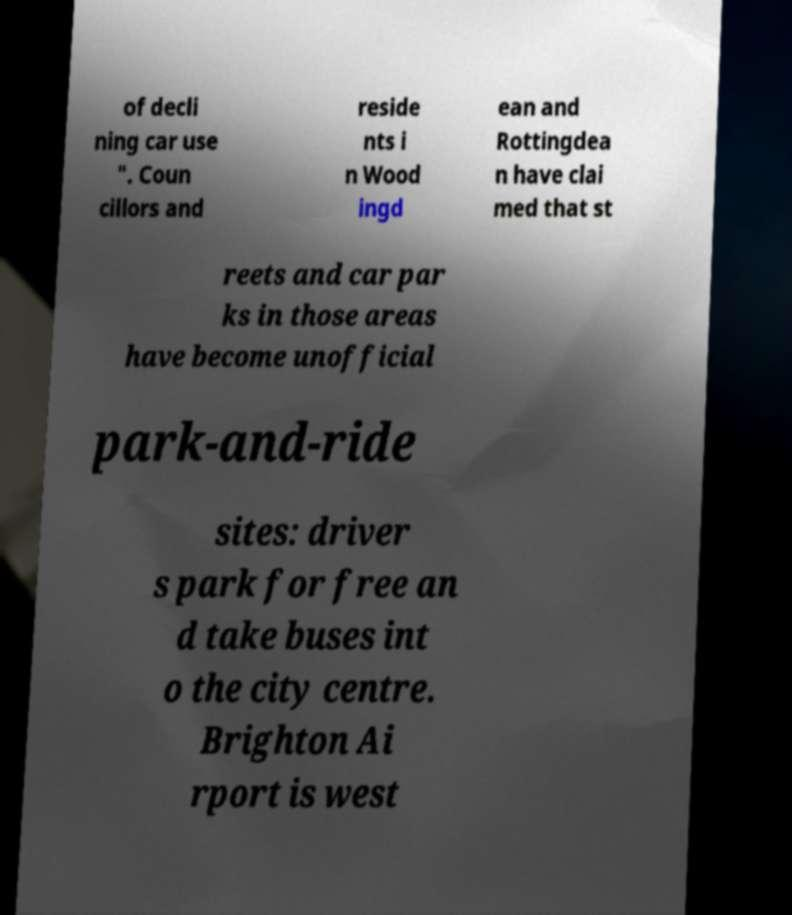What messages or text are displayed in this image? I need them in a readable, typed format. of decli ning car use ". Coun cillors and reside nts i n Wood ingd ean and Rottingdea n have clai med that st reets and car par ks in those areas have become unofficial park-and-ride sites: driver s park for free an d take buses int o the city centre. Brighton Ai rport is west 